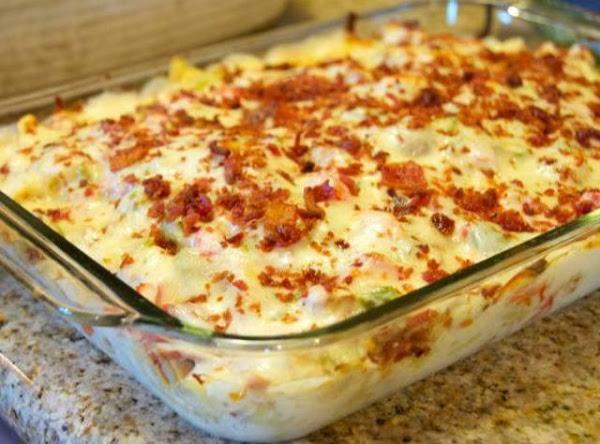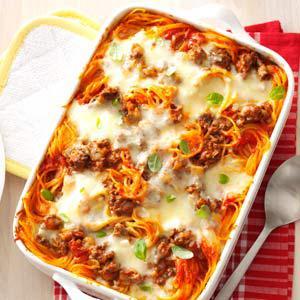The first image is the image on the left, the second image is the image on the right. Given the left and right images, does the statement "The left image shows a casserole in a rectangular white dish with a piece of silverware lying next to it on the left." hold true? Answer yes or no. No. The first image is the image on the left, the second image is the image on the right. Considering the images on both sides, is "The food in the image on the left is sitting in a white square casserole dish." valid? Answer yes or no. No. 